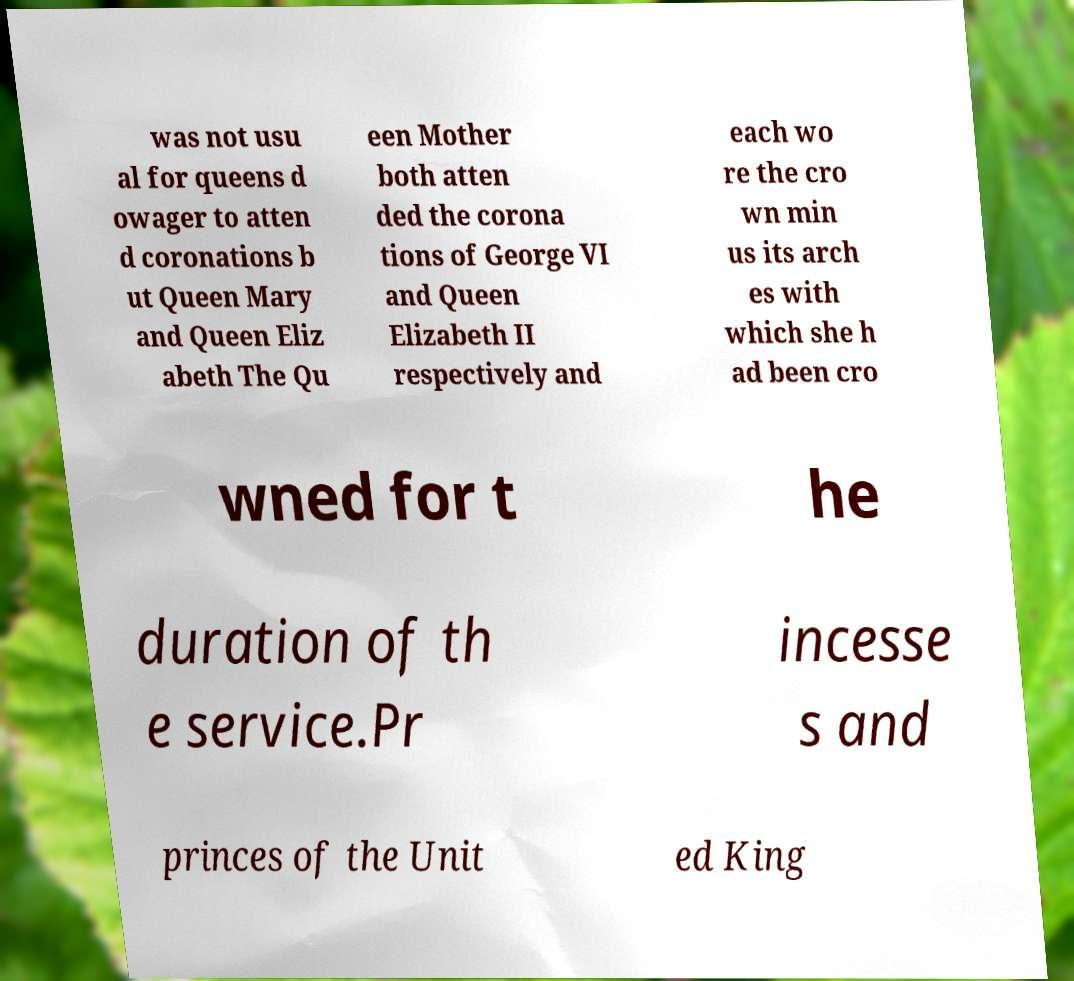There's text embedded in this image that I need extracted. Can you transcribe it verbatim? was not usu al for queens d owager to atten d coronations b ut Queen Mary and Queen Eliz abeth The Qu een Mother both atten ded the corona tions of George VI and Queen Elizabeth II respectively and each wo re the cro wn min us its arch es with which she h ad been cro wned for t he duration of th e service.Pr incesse s and princes of the Unit ed King 